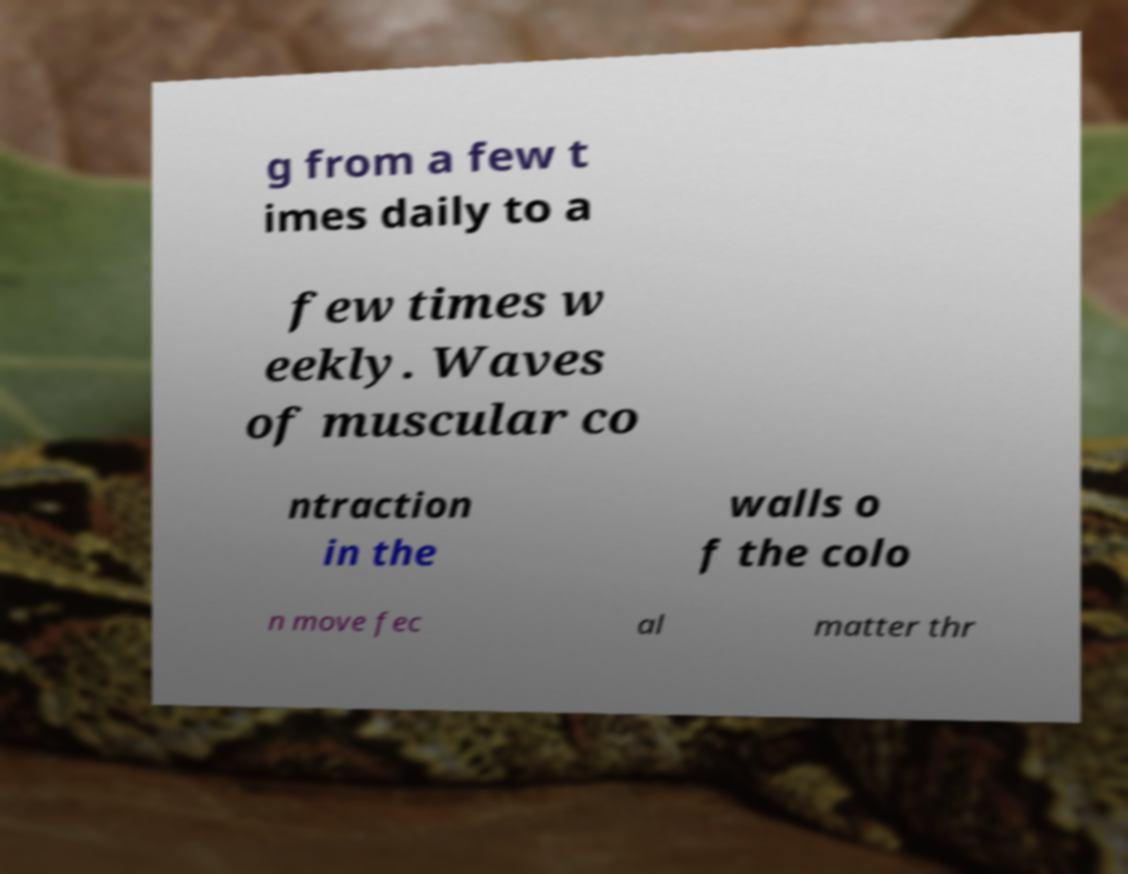Could you assist in decoding the text presented in this image and type it out clearly? g from a few t imes daily to a few times w eekly. Waves of muscular co ntraction in the walls o f the colo n move fec al matter thr 